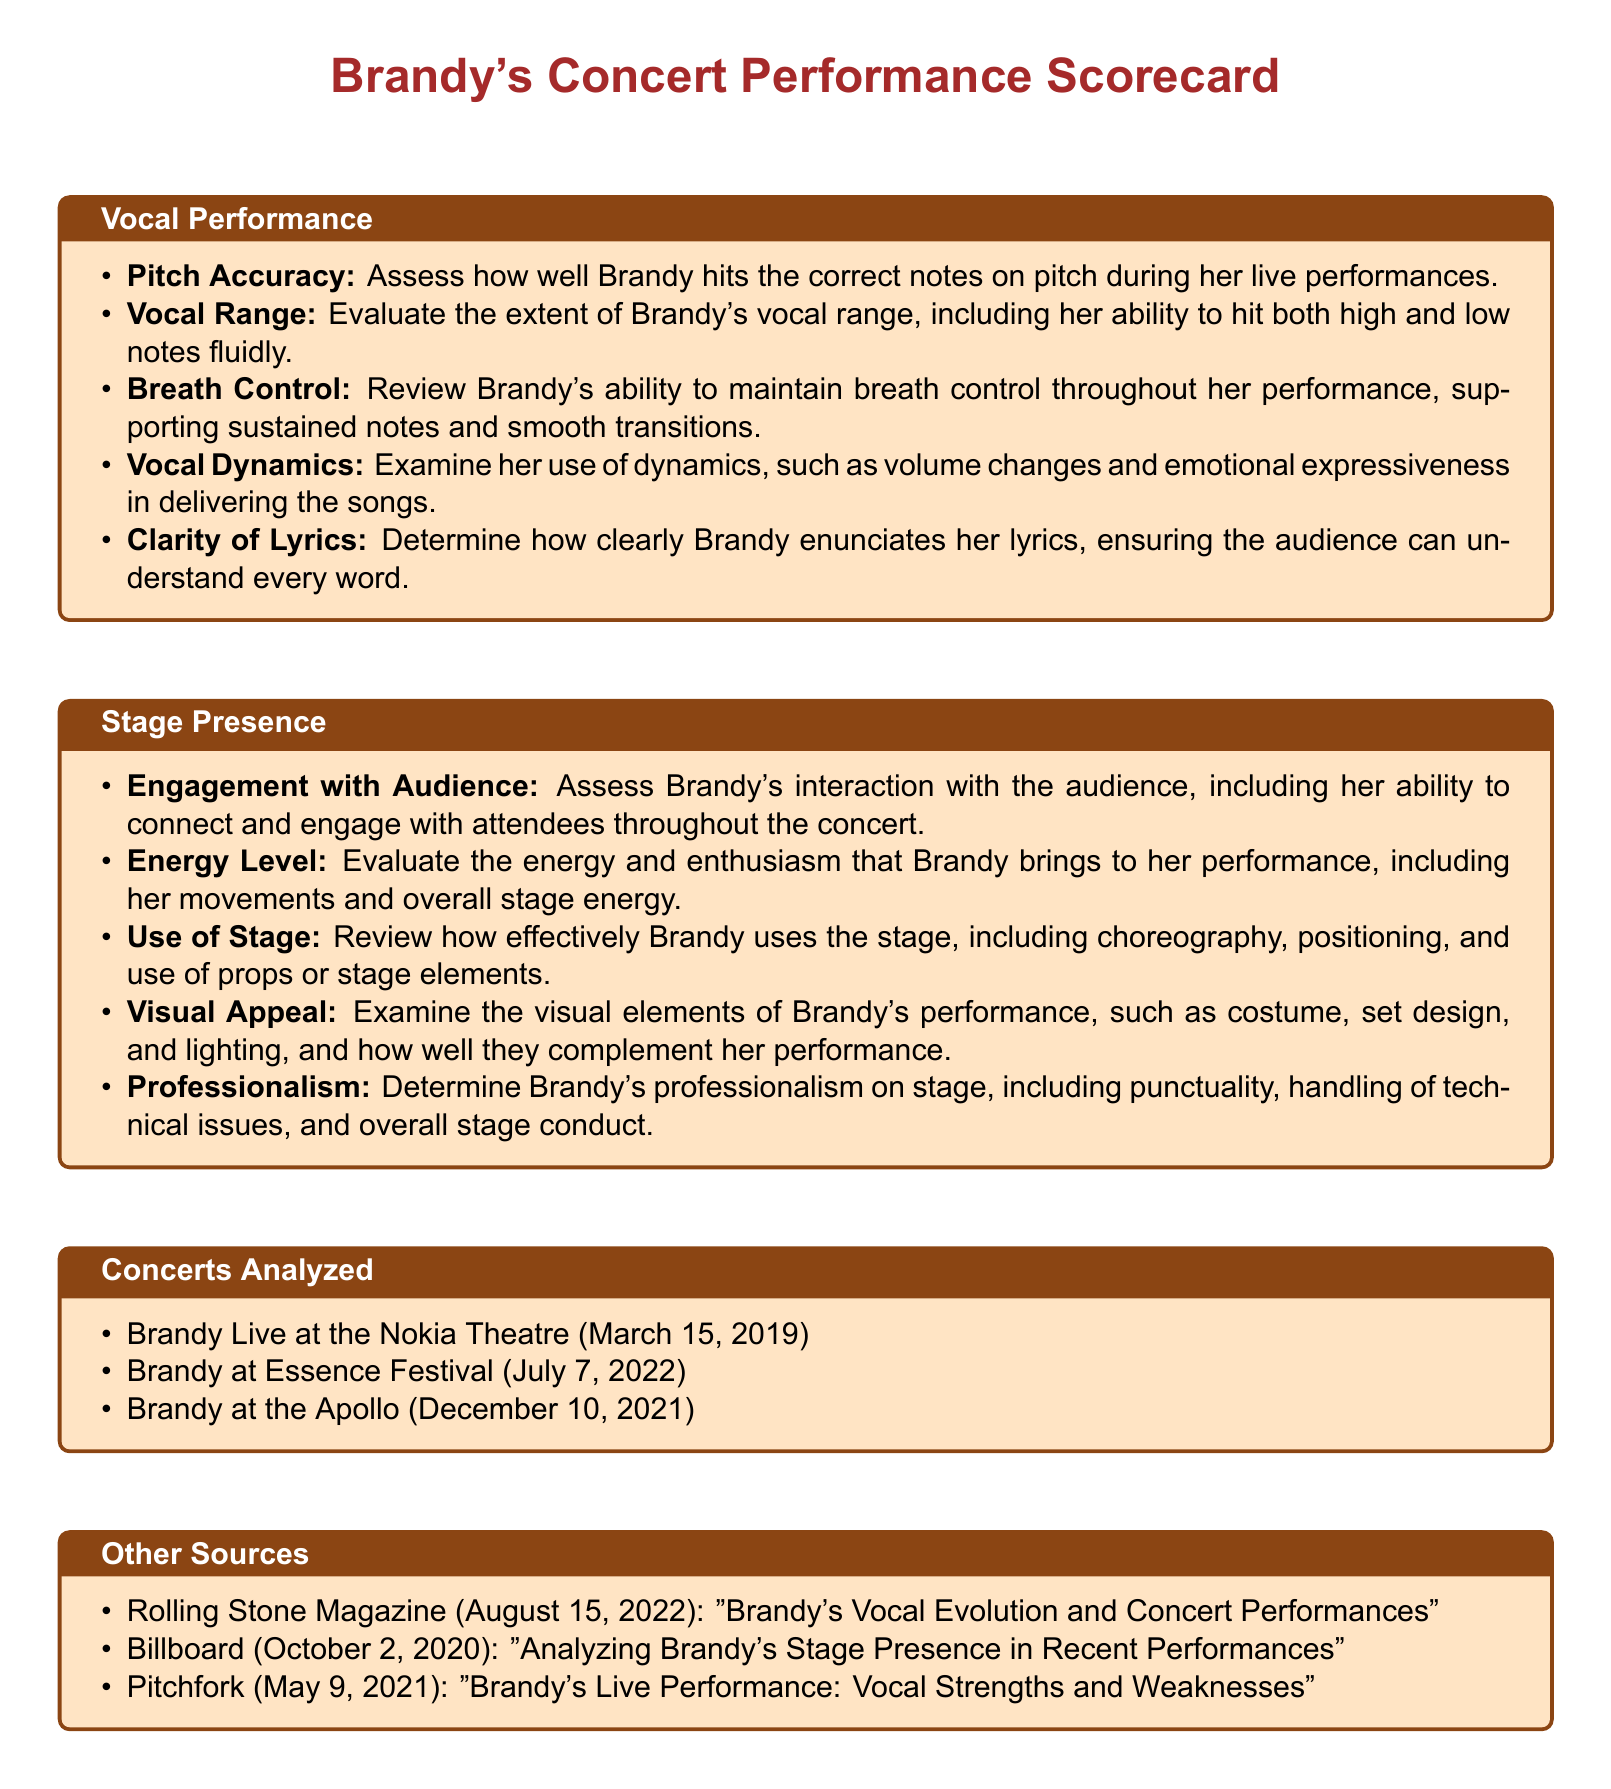what is the title of the document? The title of the document is stated at the top and is "Brandy's Concert Performance Scorecard".
Answer: Brandy's Concert Performance Scorecard how many concerts are analyzed in the document? The number of concerts analyzed is listed in the section titled "Concerts Analyzed".
Answer: 3 what is one source mentioned in the "Other Sources" section? The sources listed in "Other Sources" provide relevant information regarding Brandy's performances.
Answer: Rolling Stone Magazine which date is Brandy's concert at the Apollo? The specific date of Brandy's concert at the Apollo is provided under "Concerts Analyzed".
Answer: December 10, 2021 name one aspect of Vocal Performance evaluated in the scorecard. The scorecard includes various aspects of Vocal Performance, which are listed under the relevant section.
Answer: Pitch Accuracy what element is assessed in the Stage Presence section regarding Brandy's performance? The Stage Presence section contains multiple elements that evaluate Brandy's engagement levels and overall performance details.
Answer: Energy Level what color is used for the title in the document? The colors are mentioned in the formatting part of the document, particularly for the title.
Answer: RGB(165,42,42) how is Brandy's ability to connect with the audience described in the document? This ability is assessed under the section for Stage Presence, focusing on her interaction with the audience.
Answer: Engagement with Audience 